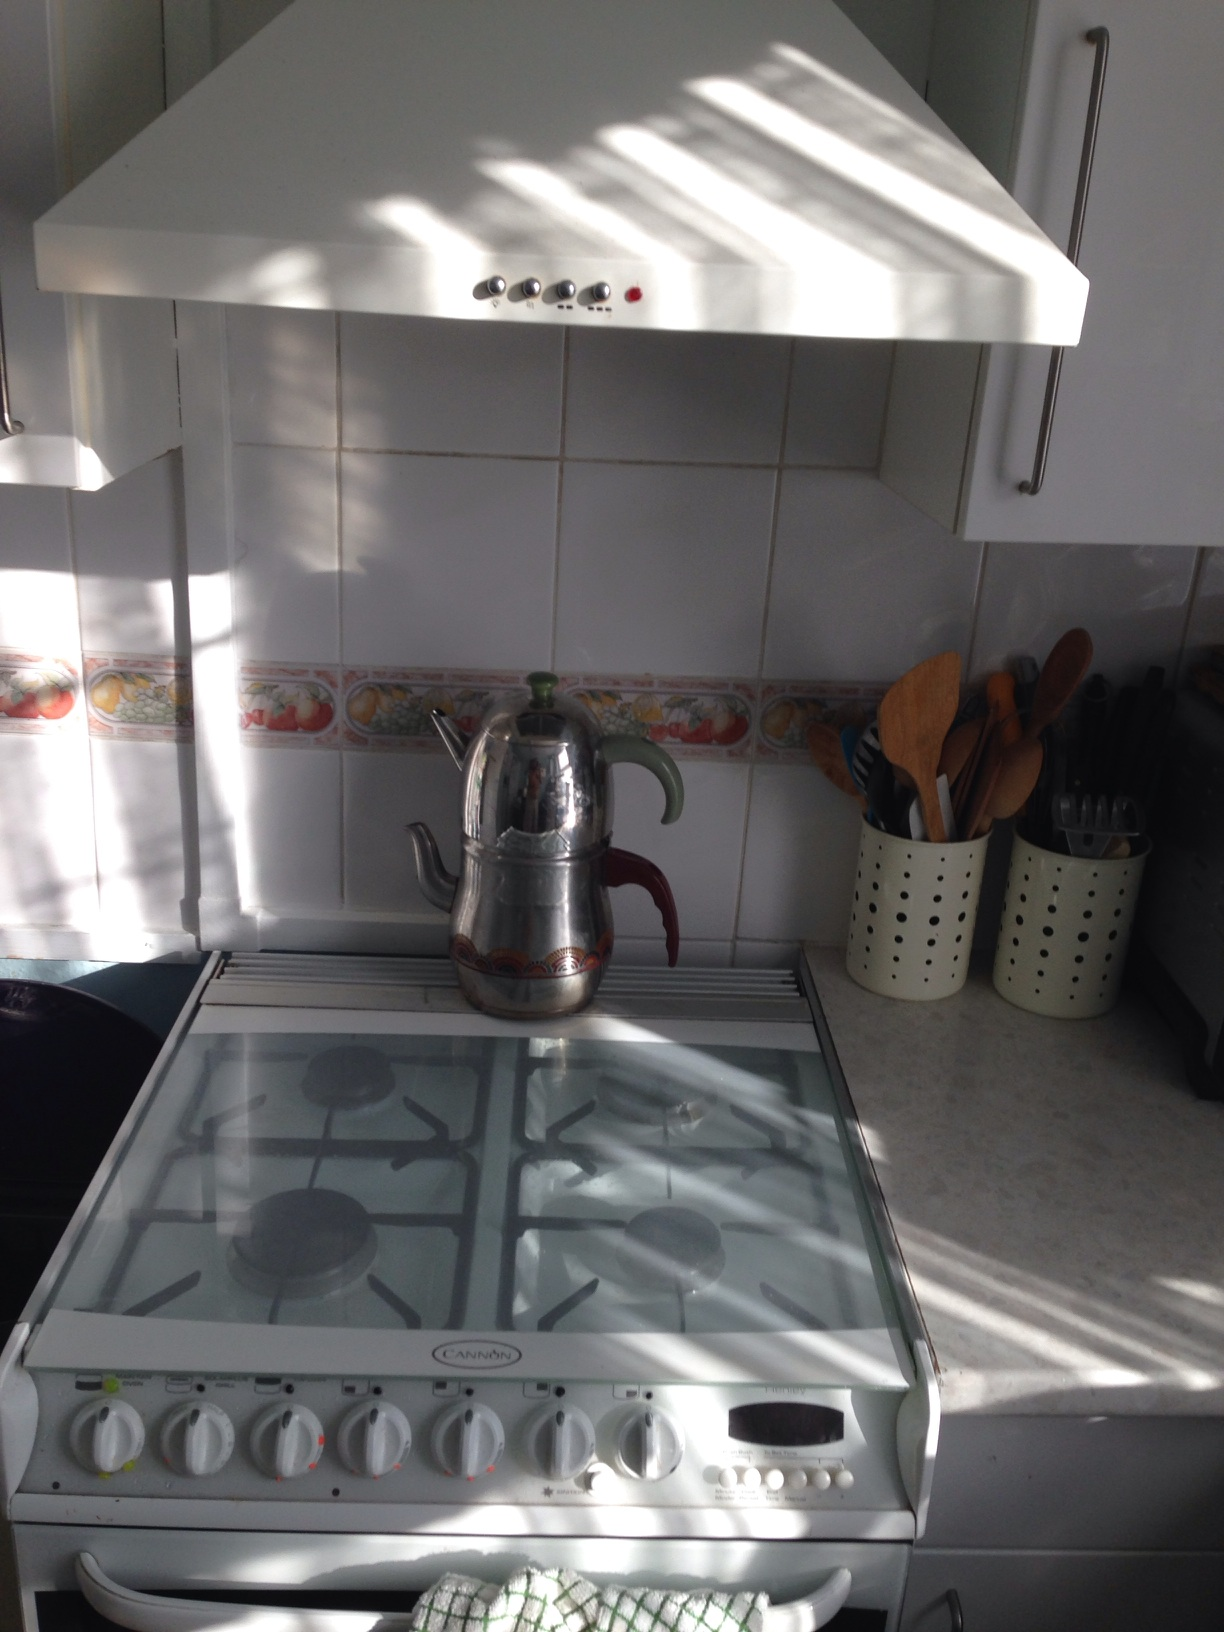Can you describe this kitchen in detail? Certainly! This kitchen features white cabinetry that gives it a clean and classic look. On the left side of the image, there is a white extractor hood above the stove, which is also white and has four gas burners. A stainless steel teapot sits on top of it, reflecting a bit of the natural light that bathes the kitchen. The backsplash includes a charming decorative border that features colorful fruit illustrations. To the right of the stove, there's a countertop with containers holding various utensils like wooden spoons, likely used for cooking and mixing ingredients. The ambient light streaming in creates a warm and inviting atmosphere, suggesting that this kitchen is a well-loved and frequently used space. 